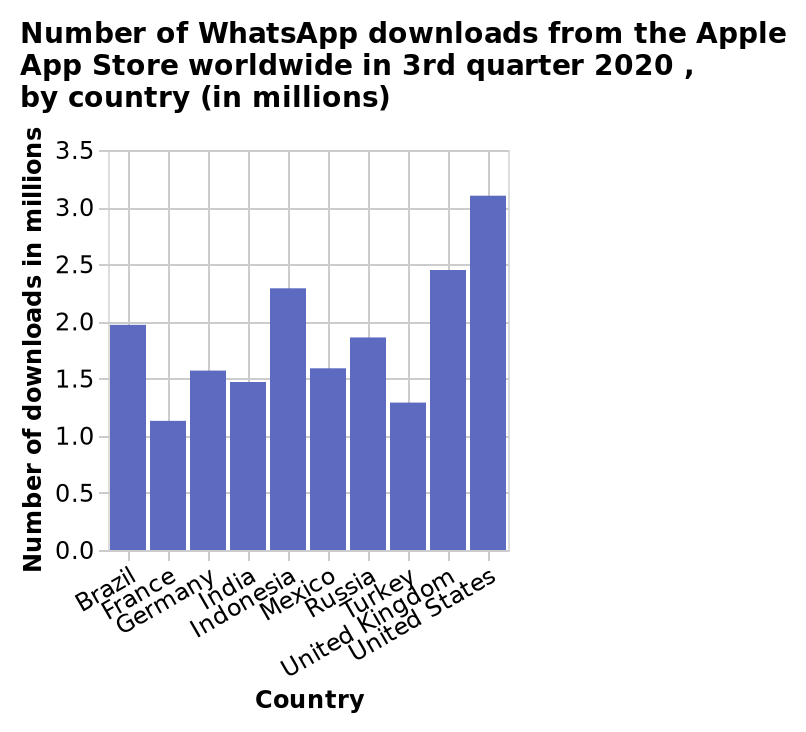<image>
How does the United States compare to other countries in terms of WhatsApp downloads in the third quarter of 2020? The United States had the highest number of WhatsApp downloads compared to any other country worldwide. please describe the details of the chart Number of WhatsApp downloads from the Apple App Store worldwide in 3rd quarter 2020 , by country (in millions) is a bar diagram. The y-axis measures Number of downloads in millions while the x-axis plots Country. 